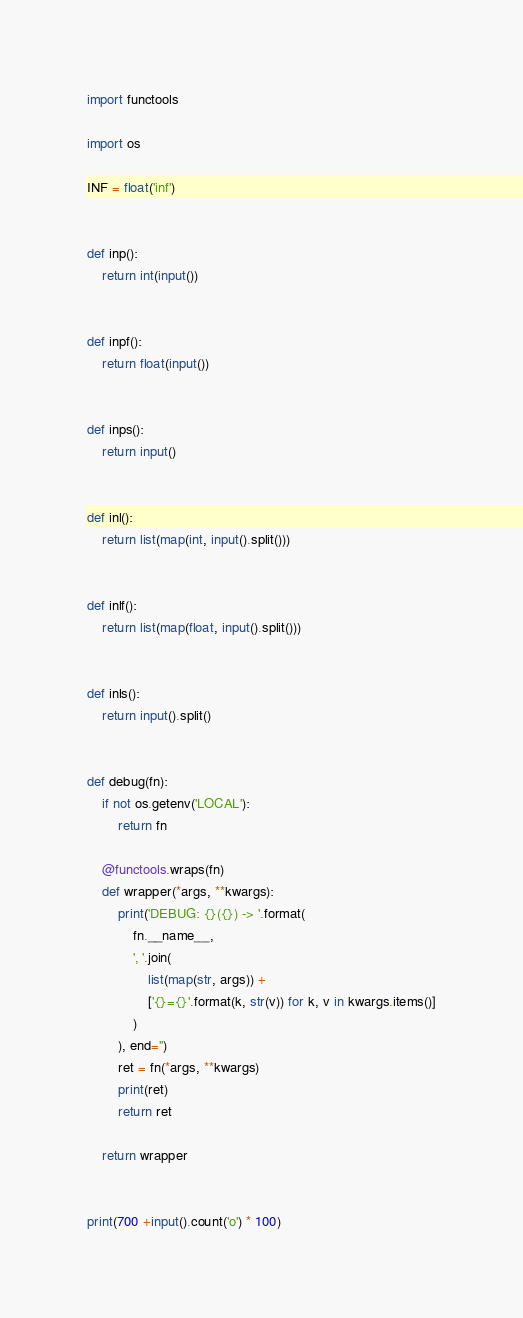Convert code to text. <code><loc_0><loc_0><loc_500><loc_500><_Python_>import functools

import os

INF = float('inf')


def inp():
    return int(input())


def inpf():
    return float(input())


def inps():
    return input()


def inl():
    return list(map(int, input().split()))


def inlf():
    return list(map(float, input().split()))


def inls():
    return input().split()


def debug(fn):
    if not os.getenv('LOCAL'):
        return fn

    @functools.wraps(fn)
    def wrapper(*args, **kwargs):
        print('DEBUG: {}({}) -> '.format(
            fn.__name__,
            ', '.join(
                list(map(str, args)) +
                ['{}={}'.format(k, str(v)) for k, v in kwargs.items()]
            )
        ), end='')
        ret = fn(*args, **kwargs)
        print(ret)
        return ret

    return wrapper


print(700 +input().count('o') * 100)
</code> 